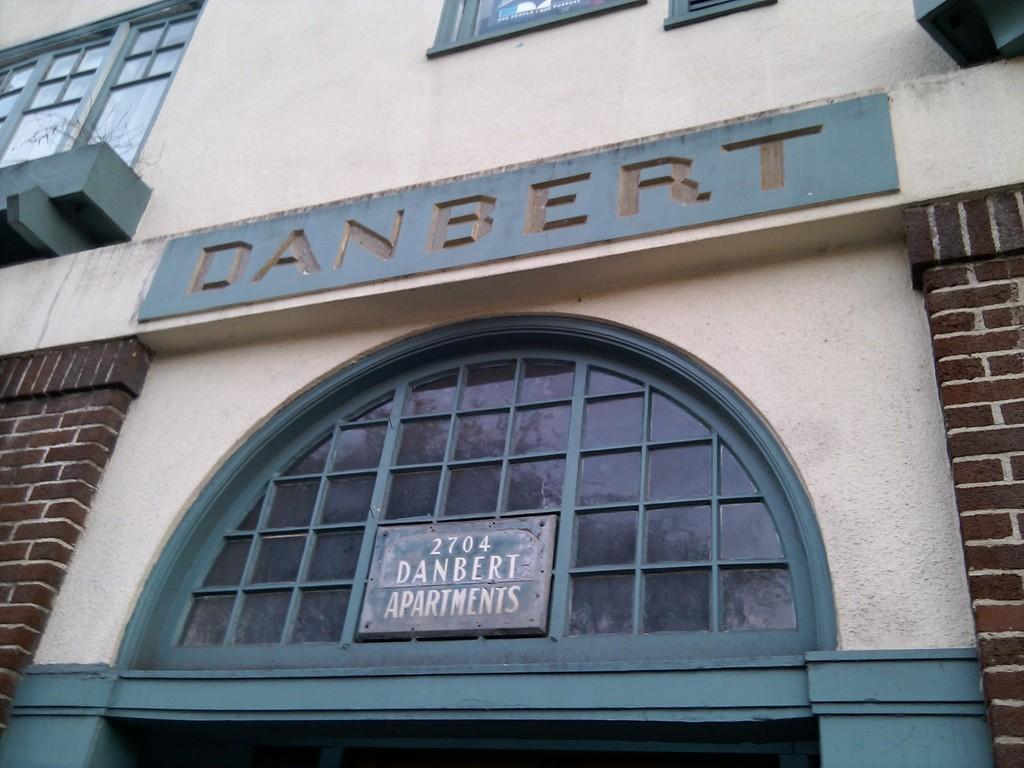What is located in front of the image? There is a name board with text on a building in front of the image. Can you describe the name board? The name board has text on it and is in front of the building. What can be seen on the left side of the image? There is a window on the left side of the image. Are there any letters visible in the image? Yes, there are letters on the wall in the image. How many men are rubbing the letters on the wall in the image? There are no men present in the image, and the letters on the wall are not being rubbed. 